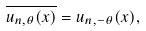<formula> <loc_0><loc_0><loc_500><loc_500>\overline { u _ { n , \theta } ( x ) } = u _ { n , - \theta } ( x ) ,</formula> 